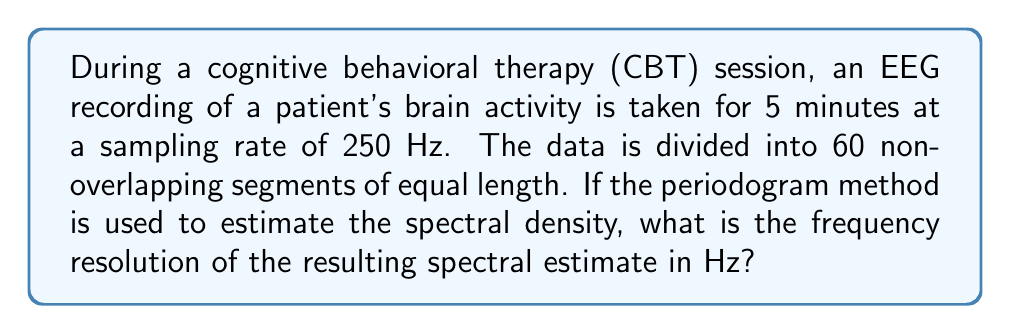Solve this math problem. To solve this problem, we need to follow these steps:

1. Calculate the total number of data points:
   Total time = 5 minutes = 300 seconds
   Sampling rate = 250 Hz
   Total data points = $300 \times 250 = 75000$

2. Determine the number of data points per segment:
   Number of segments = 60
   Data points per segment = $75000 / 60 = 1250$

3. Calculate the duration of each segment:
   Duration = Data points per segment / Sampling rate
   $$ \text{Duration} = \frac{1250}{250 \text{ Hz}} = 5 \text{ seconds} $$

4. The frequency resolution is the inverse of the segment duration:
   $$ \text{Frequency resolution} = \frac{1}{\text{Duration}} = \frac{1}{5 \text{ seconds}} = 0.2 \text{ Hz} $$

Thus, the frequency resolution of the spectral estimate is 0.2 Hz.
Answer: 0.2 Hz 